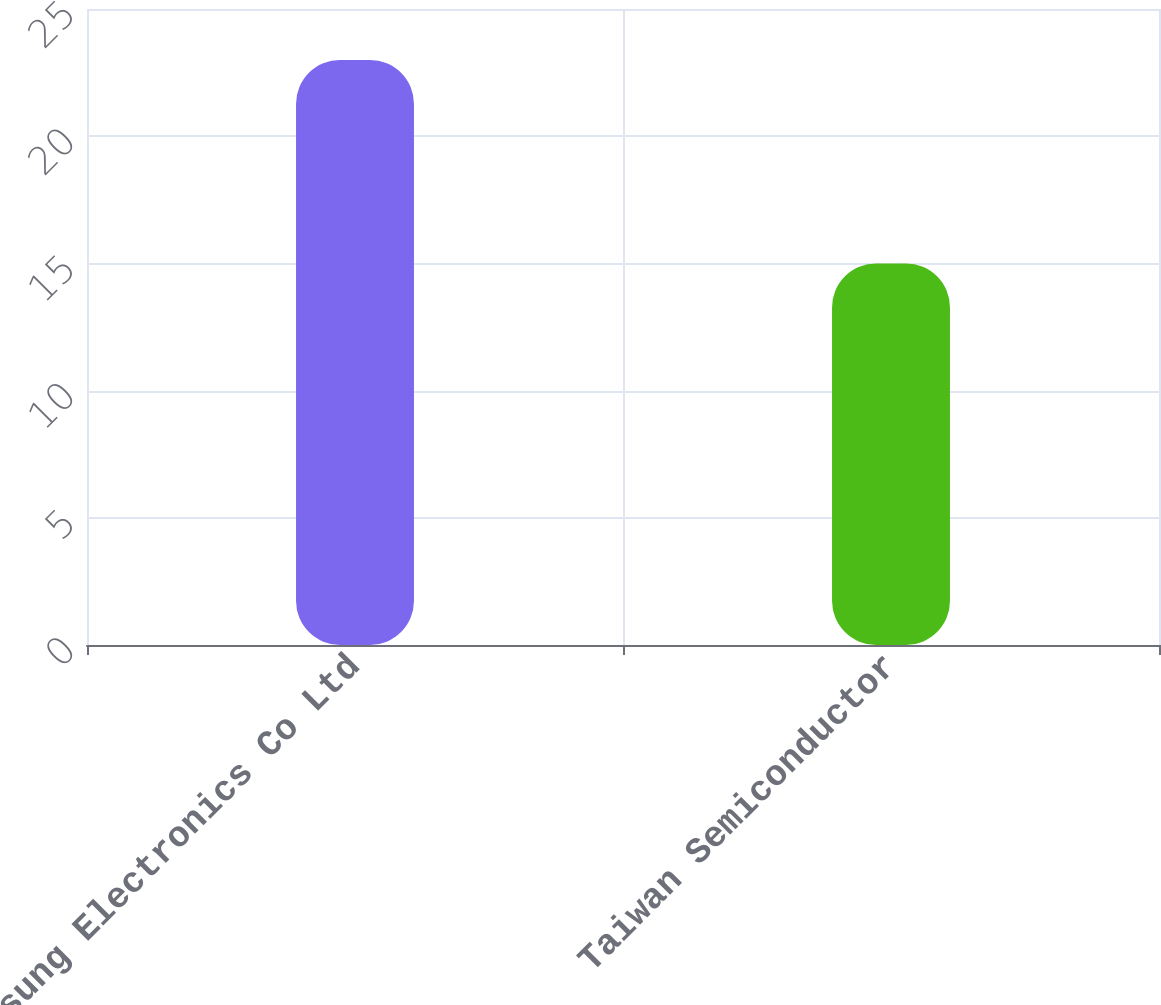Convert chart to OTSL. <chart><loc_0><loc_0><loc_500><loc_500><bar_chart><fcel>Samsung Electronics Co Ltd<fcel>Taiwan Semiconductor<nl><fcel>23<fcel>15<nl></chart> 